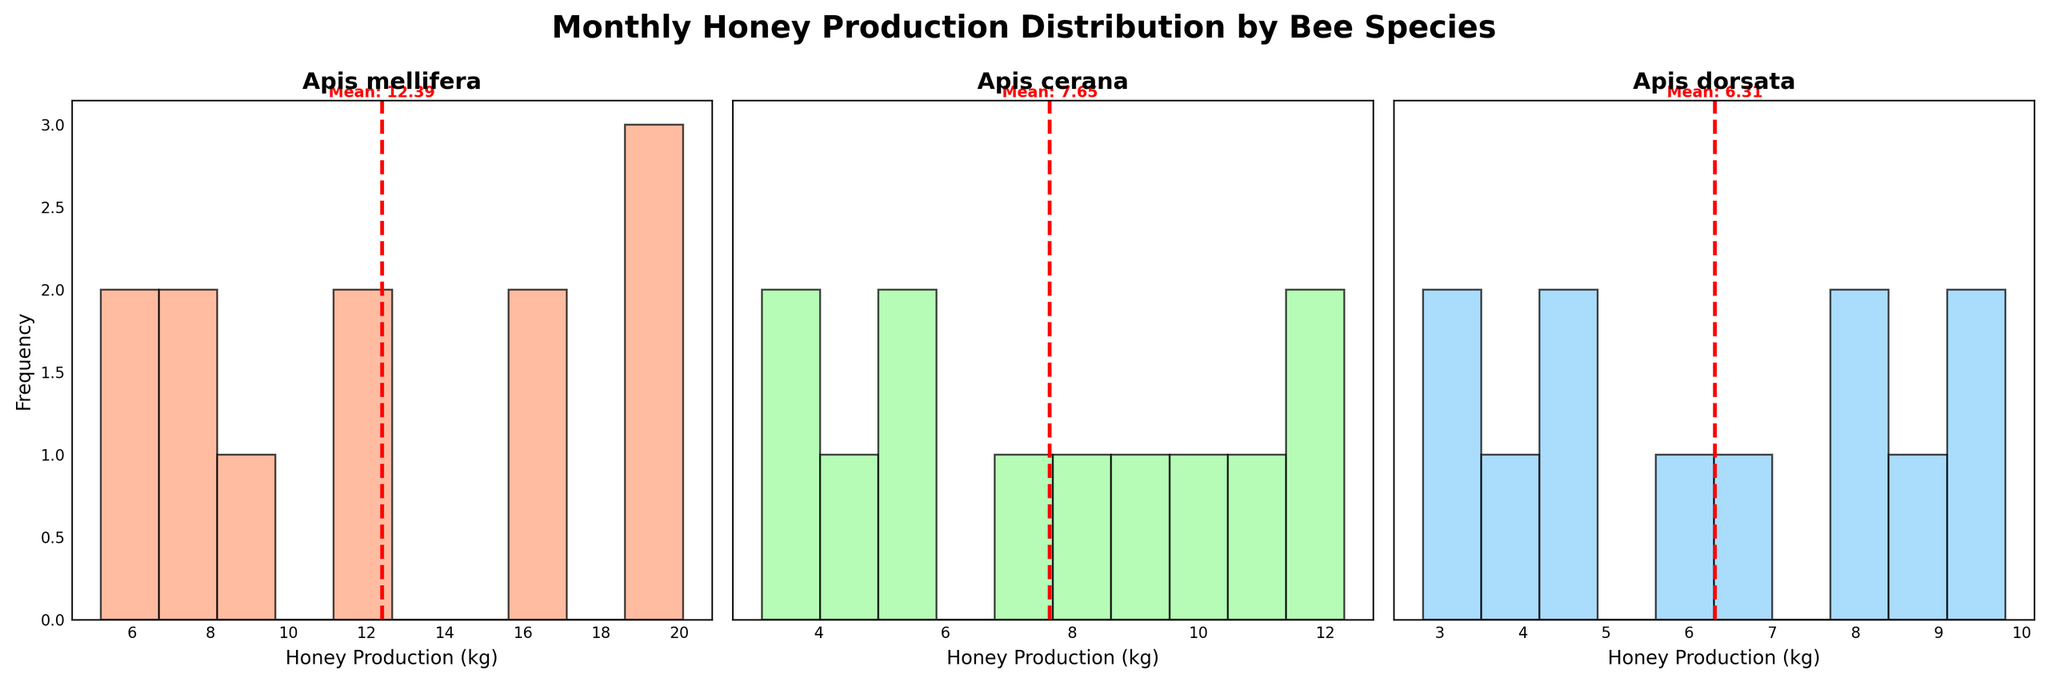Which species has the highest mean honey production? The species with the highest mean honey production is indicated by the red dashed line in each subplot. The mean value is highlighted. By comparing the three histograms, Apis mellifera has the highest mean at 12.35 kg.
Answer: Apis mellifera What is the approximate mean honey production for Apis cerana? In the subplot for Apis cerana, the red dashed line and the nearby text indicate that the mean honey production is around 7.48 kg.
Answer: 7.48 kg Which species shows the most even distribution of honey production? The most even distribution can be deduced by looking at the histogram with the most uniform frequency across bins. Apis cerana shows a relatively even distribution compared to Apis mellifera and Apis dorsata.
Answer: Apis cerana How many species have a mean honey production below 10 kg? From the figure, we see that Apis cerana and Apis dorsata have mean honey productions below the 10 kg mark as indicated by their mean lines. Therefore, 2 species fall into this category.
Answer: 2 species Which species has the least variation in monthly honey production? The species with the least variation can be identified by looking at the width and spread of the histogram. Apis dorsata has the least spread, indicating lower variation in monthly honey production.
Answer: Apis dorsata Does any species have a monthly honey production value that appears more than 5 times in the histogram? To determine this, we need to check the frequency axis of each subplot. No species has a single monthly production value that appears more than 5 times.
Answer: No Compare the highest and lowest monthly honey production for Apis mellifera. What is the difference? For Apis mellifera, the highest production is around 20.1 kg (July) and the lowest is around 5.2 kg (January). The difference is 20.1 - 5.2 = 14.9 kg.
Answer: 14.9 kg Which species has the mean honey production closest to 9 kg? Comparing the mean values of each species, Apis dorsata has a mean honey production closest to 9 kg, which is approximately 6.52 kg.
Answer: Apis dorsata 